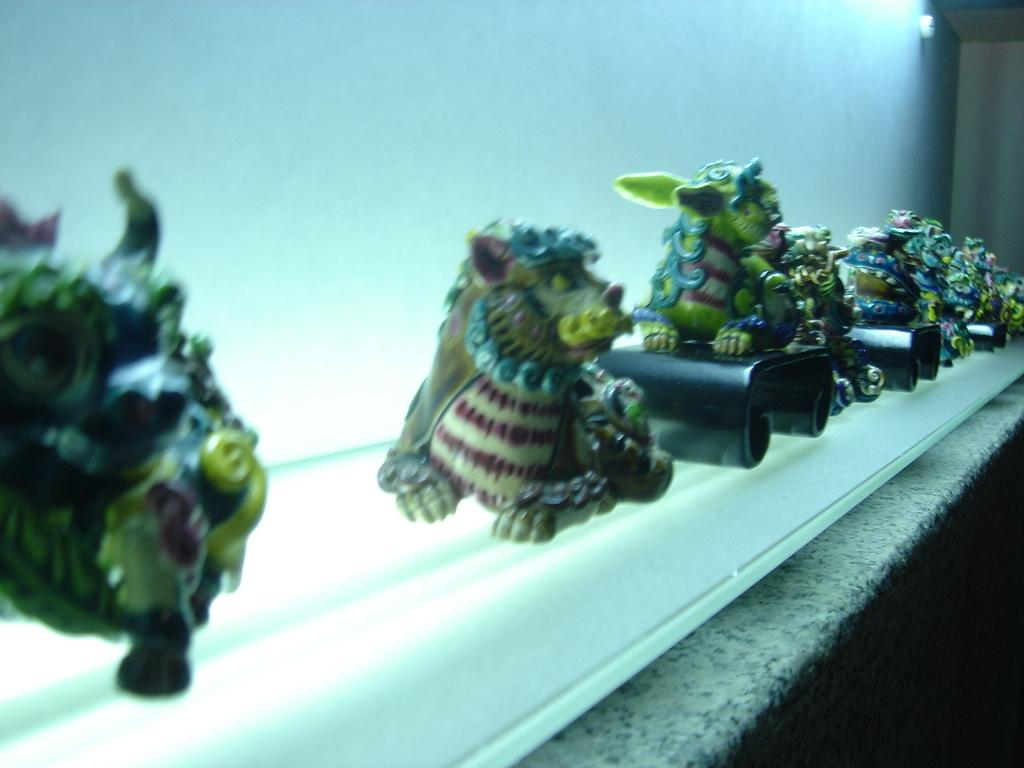What objects are present in the image? There are toys in the image. Where are the toys located? The toys are on a surface. What color is the background of the image? The background of the image is white. What type of ornament is hanging from the ceiling in the image? There is no ornament hanging from the ceiling in the image; it only features toys on a surface with a white background. 